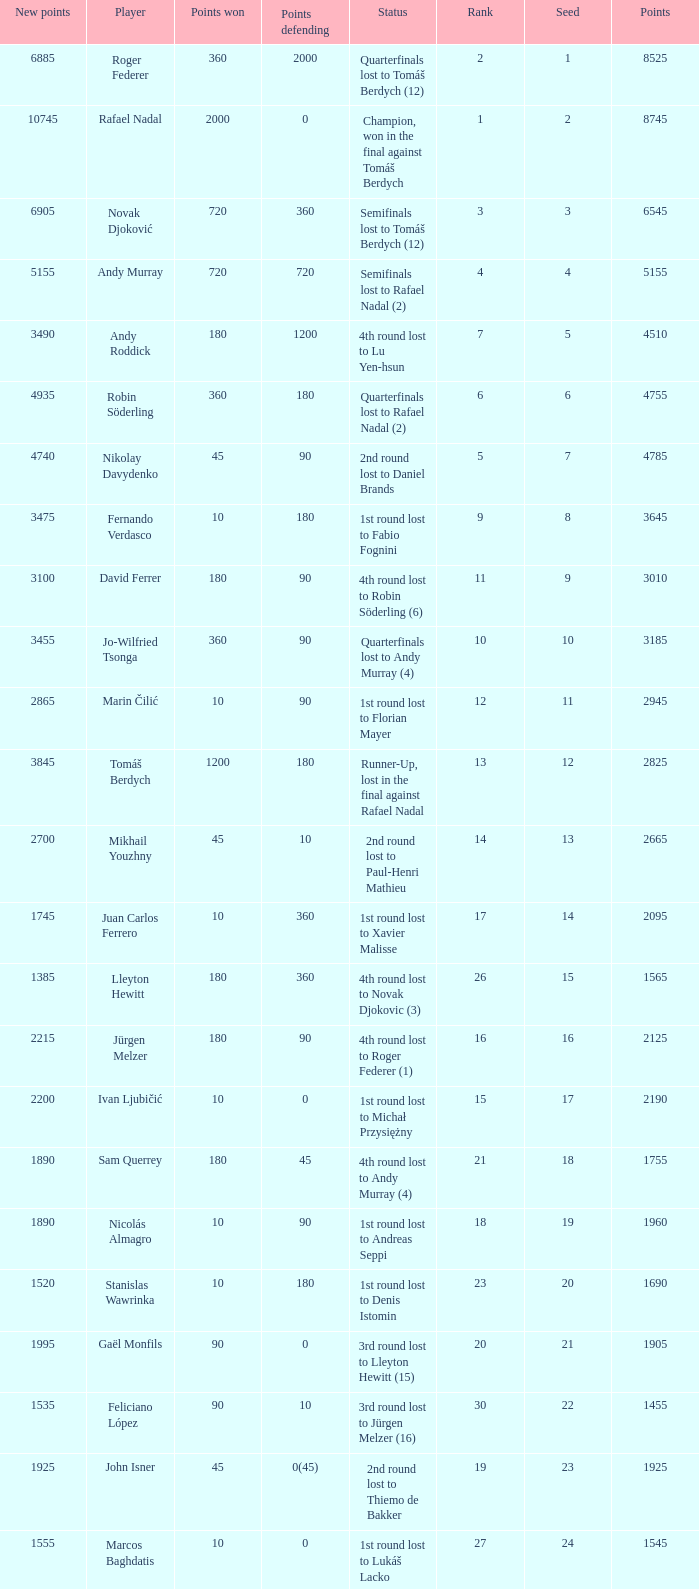Name the points won for 1230 90.0. Write the full table. {'header': ['New points', 'Player', 'Points won', 'Points defending', 'Status', 'Rank', 'Seed', 'Points'], 'rows': [['6885', 'Roger Federer', '360', '2000', 'Quarterfinals lost to Tomáš Berdych (12)', '2', '1', '8525'], ['10745', 'Rafael Nadal', '2000', '0', 'Champion, won in the final against Tomáš Berdych', '1', '2', '8745'], ['6905', 'Novak Djoković', '720', '360', 'Semifinals lost to Tomáš Berdych (12)', '3', '3', '6545'], ['5155', 'Andy Murray', '720', '720', 'Semifinals lost to Rafael Nadal (2)', '4', '4', '5155'], ['3490', 'Andy Roddick', '180', '1200', '4th round lost to Lu Yen-hsun', '7', '5', '4510'], ['4935', 'Robin Söderling', '360', '180', 'Quarterfinals lost to Rafael Nadal (2)', '6', '6', '4755'], ['4740', 'Nikolay Davydenko', '45', '90', '2nd round lost to Daniel Brands', '5', '7', '4785'], ['3475', 'Fernando Verdasco', '10', '180', '1st round lost to Fabio Fognini', '9', '8', '3645'], ['3100', 'David Ferrer', '180', '90', '4th round lost to Robin Söderling (6)', '11', '9', '3010'], ['3455', 'Jo-Wilfried Tsonga', '360', '90', 'Quarterfinals lost to Andy Murray (4)', '10', '10', '3185'], ['2865', 'Marin Čilić', '10', '90', '1st round lost to Florian Mayer', '12', '11', '2945'], ['3845', 'Tomáš Berdych', '1200', '180', 'Runner-Up, lost in the final against Rafael Nadal', '13', '12', '2825'], ['2700', 'Mikhail Youzhny', '45', '10', '2nd round lost to Paul-Henri Mathieu', '14', '13', '2665'], ['1745', 'Juan Carlos Ferrero', '10', '360', '1st round lost to Xavier Malisse', '17', '14', '2095'], ['1385', 'Lleyton Hewitt', '180', '360', '4th round lost to Novak Djokovic (3)', '26', '15', '1565'], ['2215', 'Jürgen Melzer', '180', '90', '4th round lost to Roger Federer (1)', '16', '16', '2125'], ['2200', 'Ivan Ljubičić', '10', '0', '1st round lost to Michał Przysiężny', '15', '17', '2190'], ['1890', 'Sam Querrey', '180', '45', '4th round lost to Andy Murray (4)', '21', '18', '1755'], ['1890', 'Nicolás Almagro', '10', '90', '1st round lost to Andreas Seppi', '18', '19', '1960'], ['1520', 'Stanislas Wawrinka', '10', '180', '1st round lost to Denis Istomin', '23', '20', '1690'], ['1995', 'Gaël Monfils', '90', '0', '3rd round lost to Lleyton Hewitt (15)', '20', '21', '1905'], ['1535', 'Feliciano López', '90', '10', '3rd round lost to Jürgen Melzer (16)', '30', '22', '1455'], ['1925', 'John Isner', '45', '0(45)', '2nd round lost to Thiemo de Bakker', '19', '23', '1925'], ['1555', 'Marcos Baghdatis', '10', '0', '1st round lost to Lukáš Lacko', '27', '24', '1545'], ['1722', 'Thomaz Bellucci', '90', '0(20)', '3rd round lost to Robin Söderling (6)', '24', '25', '1652'], ['1215', 'Gilles Simon', '90', '180', '3rd round lost to Andy Murray (4)', '32', '26', '1305'], ['1405', 'Albert Montañés', '90', '90', '3rd round lost to Novak Djokovic (3)', '31', '28', '1405'], ['1230', 'Philipp Kohlschreiber', '90', '90', '3rd round lost to Andy Roddick (5)', '35', '29', '1230'], ['1075', 'Tommy Robredo', '10', '90', '1st round lost to Peter Luczak', '36', '30', '1155'], ['1115', 'Victor Hănescu', '90', '45', '3rd round lost to Daniel Brands', '37', '31', '1070'], ['1229', 'Julien Benneteau', '180', '10', '4th round lost to Jo-Wilfried Tsonga (10)', '38', '32', '1059']]} 